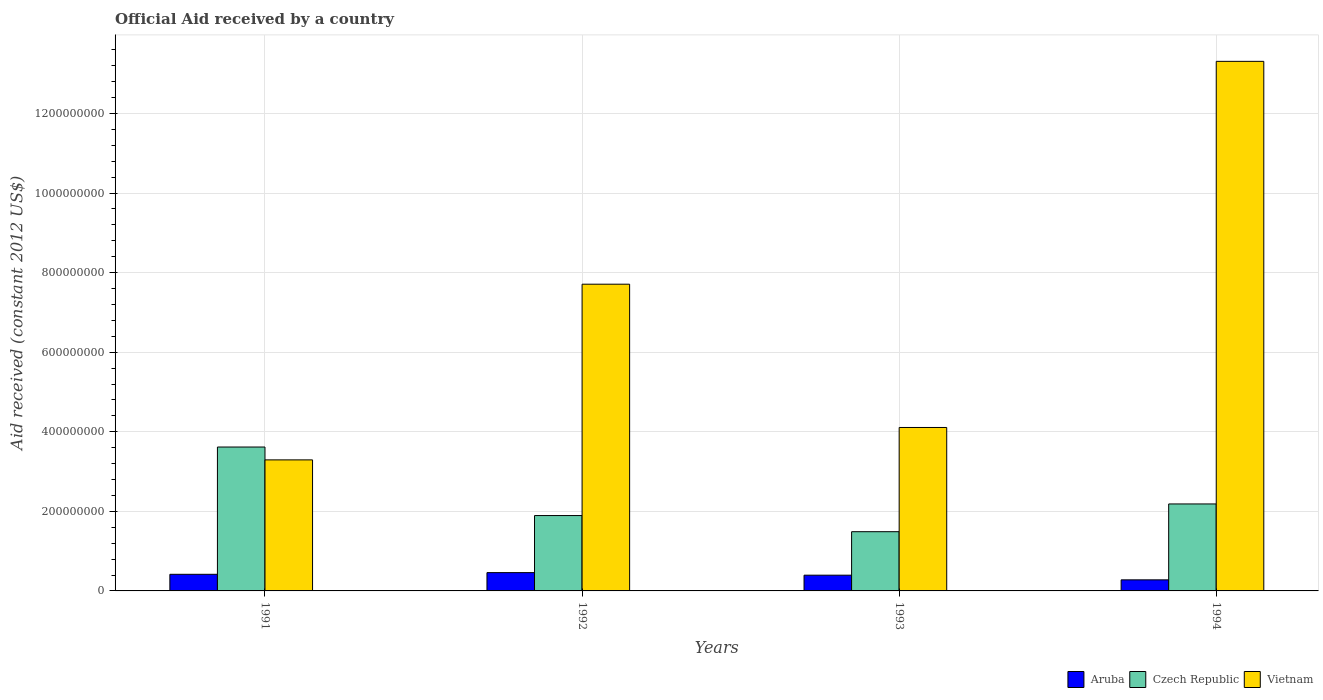How many different coloured bars are there?
Your response must be concise. 3. How many groups of bars are there?
Make the answer very short. 4. Are the number of bars per tick equal to the number of legend labels?
Ensure brevity in your answer.  Yes. Are the number of bars on each tick of the X-axis equal?
Provide a succinct answer. Yes. What is the label of the 3rd group of bars from the left?
Your answer should be compact. 1993. What is the net official aid received in Aruba in 1994?
Offer a terse response. 2.78e+07. Across all years, what is the maximum net official aid received in Aruba?
Provide a succinct answer. 4.60e+07. Across all years, what is the minimum net official aid received in Aruba?
Keep it short and to the point. 2.78e+07. What is the total net official aid received in Czech Republic in the graph?
Make the answer very short. 9.18e+08. What is the difference between the net official aid received in Vietnam in 1991 and that in 1993?
Offer a very short reply. -8.14e+07. What is the difference between the net official aid received in Vietnam in 1993 and the net official aid received in Aruba in 1994?
Offer a terse response. 3.83e+08. What is the average net official aid received in Vietnam per year?
Your answer should be compact. 7.10e+08. In the year 1992, what is the difference between the net official aid received in Vietnam and net official aid received in Aruba?
Give a very brief answer. 7.25e+08. What is the ratio of the net official aid received in Vietnam in 1992 to that in 1994?
Your answer should be compact. 0.58. What is the difference between the highest and the second highest net official aid received in Vietnam?
Ensure brevity in your answer.  5.60e+08. What is the difference between the highest and the lowest net official aid received in Aruba?
Provide a succinct answer. 1.82e+07. In how many years, is the net official aid received in Czech Republic greater than the average net official aid received in Czech Republic taken over all years?
Give a very brief answer. 1. Is the sum of the net official aid received in Czech Republic in 1992 and 1993 greater than the maximum net official aid received in Aruba across all years?
Your answer should be very brief. Yes. What does the 3rd bar from the left in 1991 represents?
Offer a very short reply. Vietnam. What does the 3rd bar from the right in 1991 represents?
Keep it short and to the point. Aruba. How many bars are there?
Provide a short and direct response. 12. Are the values on the major ticks of Y-axis written in scientific E-notation?
Your answer should be compact. No. Does the graph contain any zero values?
Make the answer very short. No. Does the graph contain grids?
Ensure brevity in your answer.  Yes. How many legend labels are there?
Offer a very short reply. 3. How are the legend labels stacked?
Offer a terse response. Horizontal. What is the title of the graph?
Your response must be concise. Official Aid received by a country. Does "Botswana" appear as one of the legend labels in the graph?
Give a very brief answer. No. What is the label or title of the Y-axis?
Provide a succinct answer. Aid received (constant 2012 US$). What is the Aid received (constant 2012 US$) in Aruba in 1991?
Make the answer very short. 4.18e+07. What is the Aid received (constant 2012 US$) in Czech Republic in 1991?
Offer a terse response. 3.62e+08. What is the Aid received (constant 2012 US$) of Vietnam in 1991?
Offer a terse response. 3.29e+08. What is the Aid received (constant 2012 US$) of Aruba in 1992?
Make the answer very short. 4.60e+07. What is the Aid received (constant 2012 US$) in Czech Republic in 1992?
Provide a succinct answer. 1.89e+08. What is the Aid received (constant 2012 US$) in Vietnam in 1992?
Provide a short and direct response. 7.71e+08. What is the Aid received (constant 2012 US$) of Aruba in 1993?
Your response must be concise. 3.96e+07. What is the Aid received (constant 2012 US$) of Czech Republic in 1993?
Provide a succinct answer. 1.49e+08. What is the Aid received (constant 2012 US$) of Vietnam in 1993?
Provide a short and direct response. 4.11e+08. What is the Aid received (constant 2012 US$) of Aruba in 1994?
Your answer should be compact. 2.78e+07. What is the Aid received (constant 2012 US$) in Czech Republic in 1994?
Ensure brevity in your answer.  2.19e+08. What is the Aid received (constant 2012 US$) in Vietnam in 1994?
Your response must be concise. 1.33e+09. Across all years, what is the maximum Aid received (constant 2012 US$) in Aruba?
Provide a short and direct response. 4.60e+07. Across all years, what is the maximum Aid received (constant 2012 US$) of Czech Republic?
Provide a short and direct response. 3.62e+08. Across all years, what is the maximum Aid received (constant 2012 US$) of Vietnam?
Offer a very short reply. 1.33e+09. Across all years, what is the minimum Aid received (constant 2012 US$) of Aruba?
Provide a succinct answer. 2.78e+07. Across all years, what is the minimum Aid received (constant 2012 US$) in Czech Republic?
Provide a short and direct response. 1.49e+08. Across all years, what is the minimum Aid received (constant 2012 US$) of Vietnam?
Provide a short and direct response. 3.29e+08. What is the total Aid received (constant 2012 US$) in Aruba in the graph?
Provide a succinct answer. 1.55e+08. What is the total Aid received (constant 2012 US$) of Czech Republic in the graph?
Provide a short and direct response. 9.18e+08. What is the total Aid received (constant 2012 US$) of Vietnam in the graph?
Give a very brief answer. 2.84e+09. What is the difference between the Aid received (constant 2012 US$) in Aruba in 1991 and that in 1992?
Give a very brief answer. -4.24e+06. What is the difference between the Aid received (constant 2012 US$) in Czech Republic in 1991 and that in 1992?
Make the answer very short. 1.72e+08. What is the difference between the Aid received (constant 2012 US$) in Vietnam in 1991 and that in 1992?
Provide a short and direct response. -4.42e+08. What is the difference between the Aid received (constant 2012 US$) of Aruba in 1991 and that in 1993?
Provide a short and direct response. 2.21e+06. What is the difference between the Aid received (constant 2012 US$) of Czech Republic in 1991 and that in 1993?
Offer a terse response. 2.13e+08. What is the difference between the Aid received (constant 2012 US$) of Vietnam in 1991 and that in 1993?
Your response must be concise. -8.14e+07. What is the difference between the Aid received (constant 2012 US$) of Aruba in 1991 and that in 1994?
Make the answer very short. 1.39e+07. What is the difference between the Aid received (constant 2012 US$) in Czech Republic in 1991 and that in 1994?
Keep it short and to the point. 1.43e+08. What is the difference between the Aid received (constant 2012 US$) in Vietnam in 1991 and that in 1994?
Keep it short and to the point. -1.00e+09. What is the difference between the Aid received (constant 2012 US$) of Aruba in 1992 and that in 1993?
Provide a short and direct response. 6.45e+06. What is the difference between the Aid received (constant 2012 US$) of Czech Republic in 1992 and that in 1993?
Your answer should be compact. 4.06e+07. What is the difference between the Aid received (constant 2012 US$) of Vietnam in 1992 and that in 1993?
Offer a terse response. 3.60e+08. What is the difference between the Aid received (constant 2012 US$) of Aruba in 1992 and that in 1994?
Ensure brevity in your answer.  1.82e+07. What is the difference between the Aid received (constant 2012 US$) in Czech Republic in 1992 and that in 1994?
Your answer should be compact. -2.92e+07. What is the difference between the Aid received (constant 2012 US$) in Vietnam in 1992 and that in 1994?
Your answer should be very brief. -5.60e+08. What is the difference between the Aid received (constant 2012 US$) in Aruba in 1993 and that in 1994?
Offer a terse response. 1.17e+07. What is the difference between the Aid received (constant 2012 US$) in Czech Republic in 1993 and that in 1994?
Offer a very short reply. -6.97e+07. What is the difference between the Aid received (constant 2012 US$) of Vietnam in 1993 and that in 1994?
Your response must be concise. -9.20e+08. What is the difference between the Aid received (constant 2012 US$) of Aruba in 1991 and the Aid received (constant 2012 US$) of Czech Republic in 1992?
Give a very brief answer. -1.48e+08. What is the difference between the Aid received (constant 2012 US$) in Aruba in 1991 and the Aid received (constant 2012 US$) in Vietnam in 1992?
Give a very brief answer. -7.29e+08. What is the difference between the Aid received (constant 2012 US$) of Czech Republic in 1991 and the Aid received (constant 2012 US$) of Vietnam in 1992?
Make the answer very short. -4.09e+08. What is the difference between the Aid received (constant 2012 US$) of Aruba in 1991 and the Aid received (constant 2012 US$) of Czech Republic in 1993?
Keep it short and to the point. -1.07e+08. What is the difference between the Aid received (constant 2012 US$) of Aruba in 1991 and the Aid received (constant 2012 US$) of Vietnam in 1993?
Keep it short and to the point. -3.69e+08. What is the difference between the Aid received (constant 2012 US$) in Czech Republic in 1991 and the Aid received (constant 2012 US$) in Vietnam in 1993?
Give a very brief answer. -4.91e+07. What is the difference between the Aid received (constant 2012 US$) in Aruba in 1991 and the Aid received (constant 2012 US$) in Czech Republic in 1994?
Your response must be concise. -1.77e+08. What is the difference between the Aid received (constant 2012 US$) of Aruba in 1991 and the Aid received (constant 2012 US$) of Vietnam in 1994?
Offer a terse response. -1.29e+09. What is the difference between the Aid received (constant 2012 US$) of Czech Republic in 1991 and the Aid received (constant 2012 US$) of Vietnam in 1994?
Offer a very short reply. -9.69e+08. What is the difference between the Aid received (constant 2012 US$) of Aruba in 1992 and the Aid received (constant 2012 US$) of Czech Republic in 1993?
Give a very brief answer. -1.03e+08. What is the difference between the Aid received (constant 2012 US$) in Aruba in 1992 and the Aid received (constant 2012 US$) in Vietnam in 1993?
Provide a succinct answer. -3.65e+08. What is the difference between the Aid received (constant 2012 US$) of Czech Republic in 1992 and the Aid received (constant 2012 US$) of Vietnam in 1993?
Offer a terse response. -2.21e+08. What is the difference between the Aid received (constant 2012 US$) of Aruba in 1992 and the Aid received (constant 2012 US$) of Czech Republic in 1994?
Ensure brevity in your answer.  -1.73e+08. What is the difference between the Aid received (constant 2012 US$) in Aruba in 1992 and the Aid received (constant 2012 US$) in Vietnam in 1994?
Ensure brevity in your answer.  -1.28e+09. What is the difference between the Aid received (constant 2012 US$) of Czech Republic in 1992 and the Aid received (constant 2012 US$) of Vietnam in 1994?
Offer a very short reply. -1.14e+09. What is the difference between the Aid received (constant 2012 US$) in Aruba in 1993 and the Aid received (constant 2012 US$) in Czech Republic in 1994?
Your answer should be very brief. -1.79e+08. What is the difference between the Aid received (constant 2012 US$) in Aruba in 1993 and the Aid received (constant 2012 US$) in Vietnam in 1994?
Provide a succinct answer. -1.29e+09. What is the difference between the Aid received (constant 2012 US$) of Czech Republic in 1993 and the Aid received (constant 2012 US$) of Vietnam in 1994?
Keep it short and to the point. -1.18e+09. What is the average Aid received (constant 2012 US$) in Aruba per year?
Give a very brief answer. 3.88e+07. What is the average Aid received (constant 2012 US$) in Czech Republic per year?
Keep it short and to the point. 2.30e+08. What is the average Aid received (constant 2012 US$) of Vietnam per year?
Keep it short and to the point. 7.10e+08. In the year 1991, what is the difference between the Aid received (constant 2012 US$) in Aruba and Aid received (constant 2012 US$) in Czech Republic?
Offer a terse response. -3.20e+08. In the year 1991, what is the difference between the Aid received (constant 2012 US$) in Aruba and Aid received (constant 2012 US$) in Vietnam?
Provide a succinct answer. -2.88e+08. In the year 1991, what is the difference between the Aid received (constant 2012 US$) of Czech Republic and Aid received (constant 2012 US$) of Vietnam?
Provide a short and direct response. 3.23e+07. In the year 1992, what is the difference between the Aid received (constant 2012 US$) of Aruba and Aid received (constant 2012 US$) of Czech Republic?
Provide a short and direct response. -1.43e+08. In the year 1992, what is the difference between the Aid received (constant 2012 US$) of Aruba and Aid received (constant 2012 US$) of Vietnam?
Ensure brevity in your answer.  -7.25e+08. In the year 1992, what is the difference between the Aid received (constant 2012 US$) of Czech Republic and Aid received (constant 2012 US$) of Vietnam?
Provide a short and direct response. -5.81e+08. In the year 1993, what is the difference between the Aid received (constant 2012 US$) of Aruba and Aid received (constant 2012 US$) of Czech Republic?
Offer a very short reply. -1.09e+08. In the year 1993, what is the difference between the Aid received (constant 2012 US$) in Aruba and Aid received (constant 2012 US$) in Vietnam?
Offer a terse response. -3.71e+08. In the year 1993, what is the difference between the Aid received (constant 2012 US$) of Czech Republic and Aid received (constant 2012 US$) of Vietnam?
Your response must be concise. -2.62e+08. In the year 1994, what is the difference between the Aid received (constant 2012 US$) in Aruba and Aid received (constant 2012 US$) in Czech Republic?
Your answer should be compact. -1.91e+08. In the year 1994, what is the difference between the Aid received (constant 2012 US$) in Aruba and Aid received (constant 2012 US$) in Vietnam?
Your response must be concise. -1.30e+09. In the year 1994, what is the difference between the Aid received (constant 2012 US$) in Czech Republic and Aid received (constant 2012 US$) in Vietnam?
Your answer should be compact. -1.11e+09. What is the ratio of the Aid received (constant 2012 US$) of Aruba in 1991 to that in 1992?
Provide a short and direct response. 0.91. What is the ratio of the Aid received (constant 2012 US$) in Czech Republic in 1991 to that in 1992?
Offer a very short reply. 1.91. What is the ratio of the Aid received (constant 2012 US$) in Vietnam in 1991 to that in 1992?
Provide a short and direct response. 0.43. What is the ratio of the Aid received (constant 2012 US$) in Aruba in 1991 to that in 1993?
Keep it short and to the point. 1.06. What is the ratio of the Aid received (constant 2012 US$) of Czech Republic in 1991 to that in 1993?
Offer a terse response. 2.43. What is the ratio of the Aid received (constant 2012 US$) in Vietnam in 1991 to that in 1993?
Offer a very short reply. 0.8. What is the ratio of the Aid received (constant 2012 US$) of Czech Republic in 1991 to that in 1994?
Your response must be concise. 1.65. What is the ratio of the Aid received (constant 2012 US$) of Vietnam in 1991 to that in 1994?
Your answer should be very brief. 0.25. What is the ratio of the Aid received (constant 2012 US$) of Aruba in 1992 to that in 1993?
Provide a short and direct response. 1.16. What is the ratio of the Aid received (constant 2012 US$) of Czech Republic in 1992 to that in 1993?
Keep it short and to the point. 1.27. What is the ratio of the Aid received (constant 2012 US$) in Vietnam in 1992 to that in 1993?
Make the answer very short. 1.88. What is the ratio of the Aid received (constant 2012 US$) in Aruba in 1992 to that in 1994?
Offer a terse response. 1.65. What is the ratio of the Aid received (constant 2012 US$) in Czech Republic in 1992 to that in 1994?
Offer a terse response. 0.87. What is the ratio of the Aid received (constant 2012 US$) of Vietnam in 1992 to that in 1994?
Provide a short and direct response. 0.58. What is the ratio of the Aid received (constant 2012 US$) in Aruba in 1993 to that in 1994?
Ensure brevity in your answer.  1.42. What is the ratio of the Aid received (constant 2012 US$) of Czech Republic in 1993 to that in 1994?
Your answer should be compact. 0.68. What is the ratio of the Aid received (constant 2012 US$) of Vietnam in 1993 to that in 1994?
Provide a short and direct response. 0.31. What is the difference between the highest and the second highest Aid received (constant 2012 US$) in Aruba?
Offer a very short reply. 4.24e+06. What is the difference between the highest and the second highest Aid received (constant 2012 US$) of Czech Republic?
Provide a short and direct response. 1.43e+08. What is the difference between the highest and the second highest Aid received (constant 2012 US$) in Vietnam?
Make the answer very short. 5.60e+08. What is the difference between the highest and the lowest Aid received (constant 2012 US$) in Aruba?
Offer a very short reply. 1.82e+07. What is the difference between the highest and the lowest Aid received (constant 2012 US$) of Czech Republic?
Provide a short and direct response. 2.13e+08. What is the difference between the highest and the lowest Aid received (constant 2012 US$) in Vietnam?
Provide a succinct answer. 1.00e+09. 